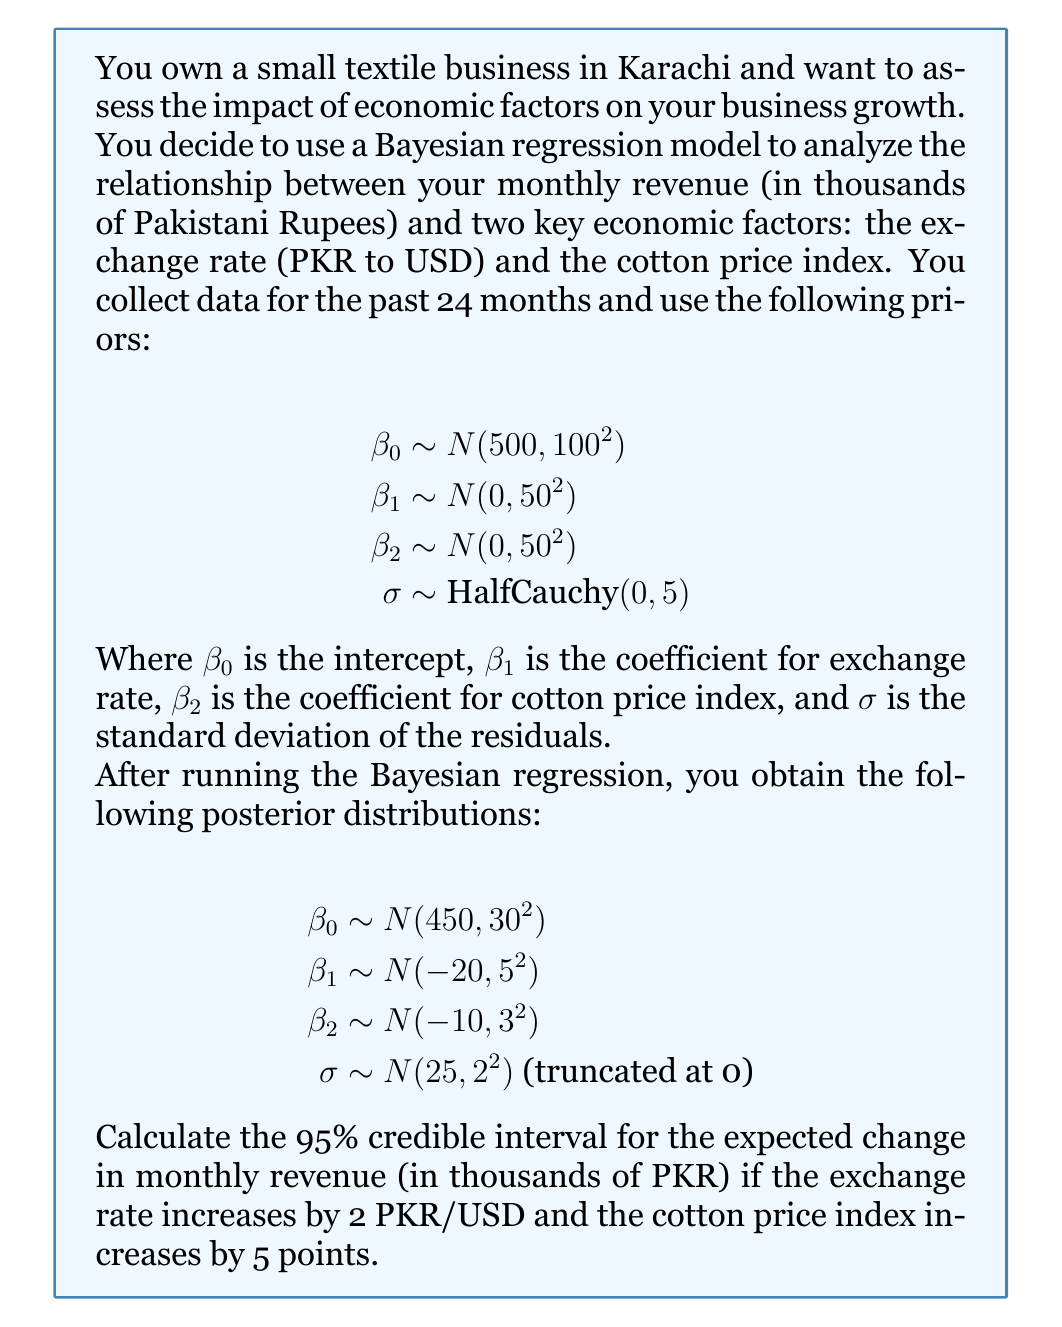Provide a solution to this math problem. To solve this problem, we need to follow these steps:

1) The model we're working with is:

   $$\text{Revenue} = \beta_0 + \beta_1 \cdot \text{ExchangeRate} + \beta_2 \cdot \text{CottonPriceIndex} + \epsilon$$

   where $\epsilon \sim N(0, \sigma^2)$

2) We're interested in the change in revenue when the exchange rate increases by 2 and the cotton price index increases by 5. This can be expressed as:

   $$\Delta \text{Revenue} = 2\beta_1 + 5\beta_2$$

3) Given the posterior distributions, we can calculate the mean and standard deviation of this linear combination:

   $$\begin{align*}
   E[\Delta \text{Revenue}] &= 2E[\beta_1] + 5E[\beta_2] \\
   &= 2(-20) + 5(-10) \\
   &= -40 - 50 = -90
   \end{align*}$$

   $$\begin{align*}
   Var[\Delta \text{Revenue}] &= 2^2 Var[\beta_1] + 5^2 Var[\beta_2] \\
   &= 4 \cdot 5^2 + 25 \cdot 3^2 \\
   &= 100 + 225 = 325
   \end{align*}$$

   $$SD[\Delta \text{Revenue}] = \sqrt{325} = 18.03$$

4) For a normal distribution, the 95% credible interval is approximately $\text{mean} \pm 1.96 \cdot \text{SD}$

5) Therefore, the 95% credible interval is:

   $$-90 \pm 1.96 \cdot 18.03 = [-125.34, -54.66]$$
Answer: The 95% credible interval for the expected change in monthly revenue is approximately [-125.34, -54.66] thousand PKR. 